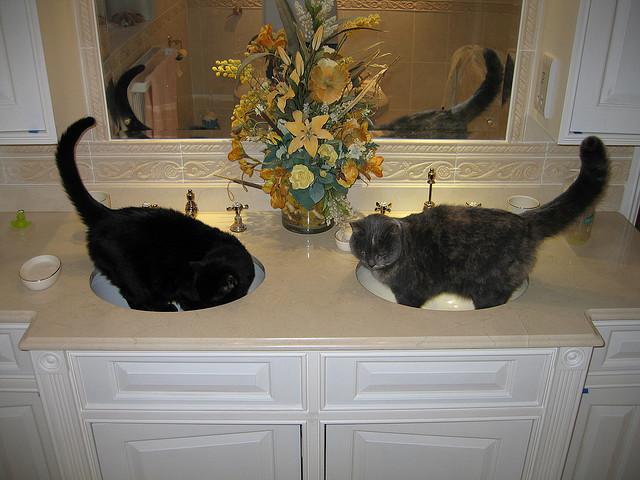Are the cats looking for water?
Give a very brief answer. Yes. What are in the sinks?
Keep it brief. Cats. How many animals are there?
Concise answer only. 2. 